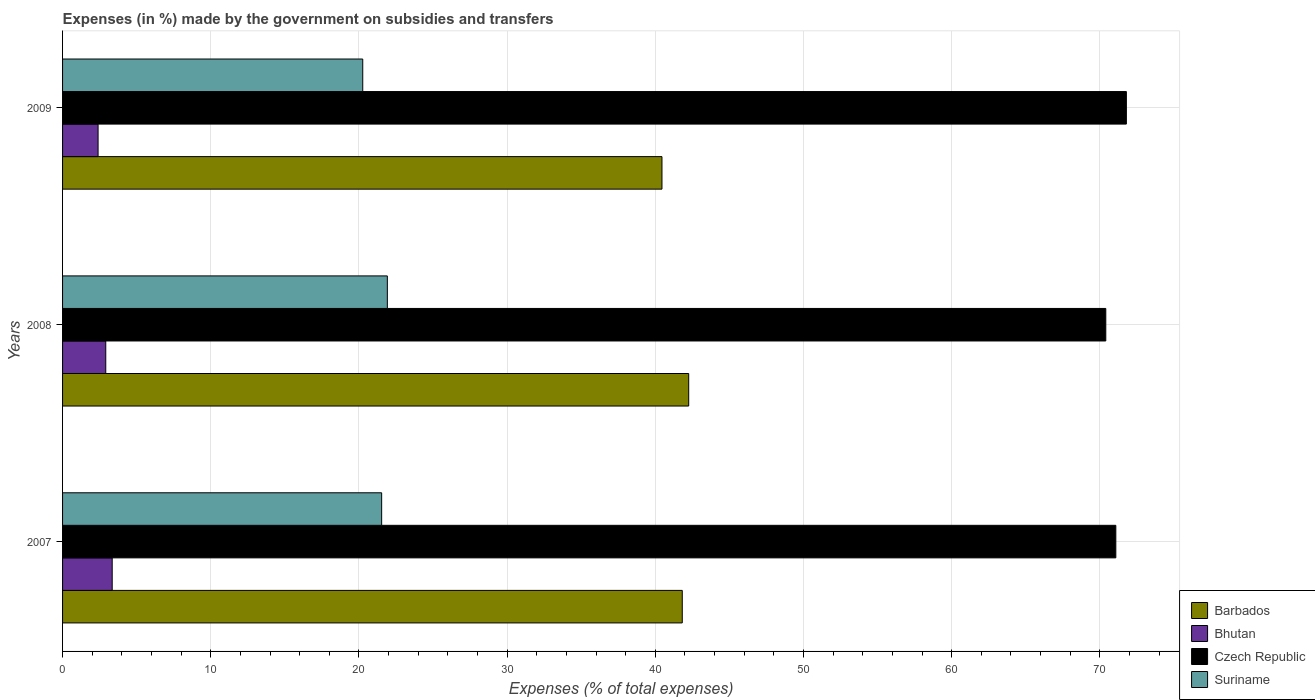Are the number of bars per tick equal to the number of legend labels?
Make the answer very short. Yes. What is the label of the 2nd group of bars from the top?
Your response must be concise. 2008. What is the percentage of expenses made by the government on subsidies and transfers in Czech Republic in 2007?
Your response must be concise. 71.08. Across all years, what is the maximum percentage of expenses made by the government on subsidies and transfers in Bhutan?
Keep it short and to the point. 3.35. Across all years, what is the minimum percentage of expenses made by the government on subsidies and transfers in Suriname?
Offer a terse response. 20.26. In which year was the percentage of expenses made by the government on subsidies and transfers in Suriname minimum?
Provide a short and direct response. 2009. What is the total percentage of expenses made by the government on subsidies and transfers in Bhutan in the graph?
Keep it short and to the point. 8.66. What is the difference between the percentage of expenses made by the government on subsidies and transfers in Barbados in 2007 and that in 2008?
Ensure brevity in your answer.  -0.44. What is the difference between the percentage of expenses made by the government on subsidies and transfers in Suriname in 2008 and the percentage of expenses made by the government on subsidies and transfers in Bhutan in 2007?
Ensure brevity in your answer.  18.57. What is the average percentage of expenses made by the government on subsidies and transfers in Czech Republic per year?
Your response must be concise. 71.09. In the year 2008, what is the difference between the percentage of expenses made by the government on subsidies and transfers in Suriname and percentage of expenses made by the government on subsidies and transfers in Czech Republic?
Provide a succinct answer. -48.49. What is the ratio of the percentage of expenses made by the government on subsidies and transfers in Bhutan in 2007 to that in 2008?
Provide a short and direct response. 1.15. What is the difference between the highest and the second highest percentage of expenses made by the government on subsidies and transfers in Bhutan?
Provide a succinct answer. 0.43. What is the difference between the highest and the lowest percentage of expenses made by the government on subsidies and transfers in Czech Republic?
Give a very brief answer. 1.39. In how many years, is the percentage of expenses made by the government on subsidies and transfers in Barbados greater than the average percentage of expenses made by the government on subsidies and transfers in Barbados taken over all years?
Ensure brevity in your answer.  2. Is it the case that in every year, the sum of the percentage of expenses made by the government on subsidies and transfers in Bhutan and percentage of expenses made by the government on subsidies and transfers in Suriname is greater than the sum of percentage of expenses made by the government on subsidies and transfers in Barbados and percentage of expenses made by the government on subsidies and transfers in Czech Republic?
Offer a very short reply. No. What does the 2nd bar from the top in 2007 represents?
Give a very brief answer. Czech Republic. What does the 4th bar from the bottom in 2008 represents?
Provide a short and direct response. Suriname. Is it the case that in every year, the sum of the percentage of expenses made by the government on subsidies and transfers in Czech Republic and percentage of expenses made by the government on subsidies and transfers in Suriname is greater than the percentage of expenses made by the government on subsidies and transfers in Barbados?
Your response must be concise. Yes. How many bars are there?
Give a very brief answer. 12. Are all the bars in the graph horizontal?
Make the answer very short. Yes. How many years are there in the graph?
Give a very brief answer. 3. Are the values on the major ticks of X-axis written in scientific E-notation?
Your response must be concise. No. Does the graph contain grids?
Offer a terse response. Yes. Where does the legend appear in the graph?
Ensure brevity in your answer.  Bottom right. How are the legend labels stacked?
Offer a very short reply. Vertical. What is the title of the graph?
Your answer should be compact. Expenses (in %) made by the government on subsidies and transfers. Does "Bahamas" appear as one of the legend labels in the graph?
Your response must be concise. No. What is the label or title of the X-axis?
Your response must be concise. Expenses (% of total expenses). What is the Expenses (% of total expenses) in Barbados in 2007?
Your answer should be compact. 41.82. What is the Expenses (% of total expenses) of Bhutan in 2007?
Provide a succinct answer. 3.35. What is the Expenses (% of total expenses) of Czech Republic in 2007?
Offer a very short reply. 71.08. What is the Expenses (% of total expenses) in Suriname in 2007?
Your answer should be very brief. 21.53. What is the Expenses (% of total expenses) of Barbados in 2008?
Provide a short and direct response. 42.26. What is the Expenses (% of total expenses) in Bhutan in 2008?
Your response must be concise. 2.92. What is the Expenses (% of total expenses) of Czech Republic in 2008?
Your answer should be compact. 70.4. What is the Expenses (% of total expenses) of Suriname in 2008?
Your response must be concise. 21.92. What is the Expenses (% of total expenses) of Barbados in 2009?
Provide a succinct answer. 40.45. What is the Expenses (% of total expenses) of Bhutan in 2009?
Make the answer very short. 2.4. What is the Expenses (% of total expenses) in Czech Republic in 2009?
Offer a very short reply. 71.79. What is the Expenses (% of total expenses) of Suriname in 2009?
Your answer should be compact. 20.26. Across all years, what is the maximum Expenses (% of total expenses) of Barbados?
Your answer should be very brief. 42.26. Across all years, what is the maximum Expenses (% of total expenses) of Bhutan?
Your answer should be very brief. 3.35. Across all years, what is the maximum Expenses (% of total expenses) in Czech Republic?
Your answer should be compact. 71.79. Across all years, what is the maximum Expenses (% of total expenses) in Suriname?
Offer a very short reply. 21.92. Across all years, what is the minimum Expenses (% of total expenses) of Barbados?
Offer a very short reply. 40.45. Across all years, what is the minimum Expenses (% of total expenses) in Bhutan?
Offer a terse response. 2.4. Across all years, what is the minimum Expenses (% of total expenses) in Czech Republic?
Give a very brief answer. 70.4. Across all years, what is the minimum Expenses (% of total expenses) of Suriname?
Offer a terse response. 20.26. What is the total Expenses (% of total expenses) in Barbados in the graph?
Keep it short and to the point. 124.53. What is the total Expenses (% of total expenses) of Bhutan in the graph?
Give a very brief answer. 8.66. What is the total Expenses (% of total expenses) in Czech Republic in the graph?
Keep it short and to the point. 213.27. What is the total Expenses (% of total expenses) of Suriname in the graph?
Provide a succinct answer. 63.71. What is the difference between the Expenses (% of total expenses) of Barbados in 2007 and that in 2008?
Provide a succinct answer. -0.44. What is the difference between the Expenses (% of total expenses) in Bhutan in 2007 and that in 2008?
Offer a terse response. 0.43. What is the difference between the Expenses (% of total expenses) in Czech Republic in 2007 and that in 2008?
Your response must be concise. 0.68. What is the difference between the Expenses (% of total expenses) in Suriname in 2007 and that in 2008?
Offer a terse response. -0.38. What is the difference between the Expenses (% of total expenses) in Barbados in 2007 and that in 2009?
Offer a terse response. 1.37. What is the difference between the Expenses (% of total expenses) of Bhutan in 2007 and that in 2009?
Offer a terse response. 0.95. What is the difference between the Expenses (% of total expenses) of Czech Republic in 2007 and that in 2009?
Your answer should be very brief. -0.71. What is the difference between the Expenses (% of total expenses) in Suriname in 2007 and that in 2009?
Make the answer very short. 1.28. What is the difference between the Expenses (% of total expenses) of Barbados in 2008 and that in 2009?
Your answer should be very brief. 1.8. What is the difference between the Expenses (% of total expenses) in Bhutan in 2008 and that in 2009?
Make the answer very short. 0.52. What is the difference between the Expenses (% of total expenses) in Czech Republic in 2008 and that in 2009?
Your answer should be compact. -1.39. What is the difference between the Expenses (% of total expenses) of Suriname in 2008 and that in 2009?
Provide a succinct answer. 1.66. What is the difference between the Expenses (% of total expenses) of Barbados in 2007 and the Expenses (% of total expenses) of Bhutan in 2008?
Your response must be concise. 38.9. What is the difference between the Expenses (% of total expenses) of Barbados in 2007 and the Expenses (% of total expenses) of Czech Republic in 2008?
Your answer should be very brief. -28.58. What is the difference between the Expenses (% of total expenses) in Barbados in 2007 and the Expenses (% of total expenses) in Suriname in 2008?
Offer a terse response. 19.9. What is the difference between the Expenses (% of total expenses) of Bhutan in 2007 and the Expenses (% of total expenses) of Czech Republic in 2008?
Give a very brief answer. -67.05. What is the difference between the Expenses (% of total expenses) in Bhutan in 2007 and the Expenses (% of total expenses) in Suriname in 2008?
Provide a succinct answer. -18.57. What is the difference between the Expenses (% of total expenses) in Czech Republic in 2007 and the Expenses (% of total expenses) in Suriname in 2008?
Ensure brevity in your answer.  49.16. What is the difference between the Expenses (% of total expenses) of Barbados in 2007 and the Expenses (% of total expenses) of Bhutan in 2009?
Give a very brief answer. 39.42. What is the difference between the Expenses (% of total expenses) in Barbados in 2007 and the Expenses (% of total expenses) in Czech Republic in 2009?
Make the answer very short. -29.97. What is the difference between the Expenses (% of total expenses) in Barbados in 2007 and the Expenses (% of total expenses) in Suriname in 2009?
Your answer should be very brief. 21.56. What is the difference between the Expenses (% of total expenses) in Bhutan in 2007 and the Expenses (% of total expenses) in Czech Republic in 2009?
Offer a terse response. -68.44. What is the difference between the Expenses (% of total expenses) of Bhutan in 2007 and the Expenses (% of total expenses) of Suriname in 2009?
Provide a short and direct response. -16.91. What is the difference between the Expenses (% of total expenses) of Czech Republic in 2007 and the Expenses (% of total expenses) of Suriname in 2009?
Ensure brevity in your answer.  50.82. What is the difference between the Expenses (% of total expenses) in Barbados in 2008 and the Expenses (% of total expenses) in Bhutan in 2009?
Offer a very short reply. 39.86. What is the difference between the Expenses (% of total expenses) of Barbados in 2008 and the Expenses (% of total expenses) of Czech Republic in 2009?
Your answer should be very brief. -29.54. What is the difference between the Expenses (% of total expenses) of Barbados in 2008 and the Expenses (% of total expenses) of Suriname in 2009?
Your response must be concise. 22. What is the difference between the Expenses (% of total expenses) of Bhutan in 2008 and the Expenses (% of total expenses) of Czech Republic in 2009?
Offer a terse response. -68.88. What is the difference between the Expenses (% of total expenses) in Bhutan in 2008 and the Expenses (% of total expenses) in Suriname in 2009?
Offer a terse response. -17.34. What is the difference between the Expenses (% of total expenses) of Czech Republic in 2008 and the Expenses (% of total expenses) of Suriname in 2009?
Provide a succinct answer. 50.15. What is the average Expenses (% of total expenses) in Barbados per year?
Your answer should be compact. 41.51. What is the average Expenses (% of total expenses) in Bhutan per year?
Make the answer very short. 2.89. What is the average Expenses (% of total expenses) in Czech Republic per year?
Provide a short and direct response. 71.09. What is the average Expenses (% of total expenses) in Suriname per year?
Offer a terse response. 21.24. In the year 2007, what is the difference between the Expenses (% of total expenses) in Barbados and Expenses (% of total expenses) in Bhutan?
Offer a very short reply. 38.47. In the year 2007, what is the difference between the Expenses (% of total expenses) in Barbados and Expenses (% of total expenses) in Czech Republic?
Give a very brief answer. -29.26. In the year 2007, what is the difference between the Expenses (% of total expenses) in Barbados and Expenses (% of total expenses) in Suriname?
Make the answer very short. 20.29. In the year 2007, what is the difference between the Expenses (% of total expenses) of Bhutan and Expenses (% of total expenses) of Czech Republic?
Make the answer very short. -67.73. In the year 2007, what is the difference between the Expenses (% of total expenses) in Bhutan and Expenses (% of total expenses) in Suriname?
Provide a succinct answer. -18.18. In the year 2007, what is the difference between the Expenses (% of total expenses) of Czech Republic and Expenses (% of total expenses) of Suriname?
Your answer should be compact. 49.55. In the year 2008, what is the difference between the Expenses (% of total expenses) in Barbados and Expenses (% of total expenses) in Bhutan?
Your answer should be compact. 39.34. In the year 2008, what is the difference between the Expenses (% of total expenses) of Barbados and Expenses (% of total expenses) of Czech Republic?
Provide a succinct answer. -28.15. In the year 2008, what is the difference between the Expenses (% of total expenses) in Barbados and Expenses (% of total expenses) in Suriname?
Your answer should be compact. 20.34. In the year 2008, what is the difference between the Expenses (% of total expenses) of Bhutan and Expenses (% of total expenses) of Czech Republic?
Your response must be concise. -67.49. In the year 2008, what is the difference between the Expenses (% of total expenses) of Bhutan and Expenses (% of total expenses) of Suriname?
Offer a very short reply. -19. In the year 2008, what is the difference between the Expenses (% of total expenses) of Czech Republic and Expenses (% of total expenses) of Suriname?
Your response must be concise. 48.49. In the year 2009, what is the difference between the Expenses (% of total expenses) in Barbados and Expenses (% of total expenses) in Bhutan?
Your answer should be compact. 38.05. In the year 2009, what is the difference between the Expenses (% of total expenses) in Barbados and Expenses (% of total expenses) in Czech Republic?
Provide a succinct answer. -31.34. In the year 2009, what is the difference between the Expenses (% of total expenses) in Barbados and Expenses (% of total expenses) in Suriname?
Provide a short and direct response. 20.19. In the year 2009, what is the difference between the Expenses (% of total expenses) in Bhutan and Expenses (% of total expenses) in Czech Republic?
Ensure brevity in your answer.  -69.39. In the year 2009, what is the difference between the Expenses (% of total expenses) of Bhutan and Expenses (% of total expenses) of Suriname?
Your answer should be compact. -17.86. In the year 2009, what is the difference between the Expenses (% of total expenses) of Czech Republic and Expenses (% of total expenses) of Suriname?
Give a very brief answer. 51.53. What is the ratio of the Expenses (% of total expenses) of Bhutan in 2007 to that in 2008?
Make the answer very short. 1.15. What is the ratio of the Expenses (% of total expenses) in Czech Republic in 2007 to that in 2008?
Make the answer very short. 1.01. What is the ratio of the Expenses (% of total expenses) in Suriname in 2007 to that in 2008?
Provide a short and direct response. 0.98. What is the ratio of the Expenses (% of total expenses) in Barbados in 2007 to that in 2009?
Make the answer very short. 1.03. What is the ratio of the Expenses (% of total expenses) of Bhutan in 2007 to that in 2009?
Provide a succinct answer. 1.4. What is the ratio of the Expenses (% of total expenses) of Suriname in 2007 to that in 2009?
Provide a short and direct response. 1.06. What is the ratio of the Expenses (% of total expenses) of Barbados in 2008 to that in 2009?
Give a very brief answer. 1.04. What is the ratio of the Expenses (% of total expenses) in Bhutan in 2008 to that in 2009?
Provide a short and direct response. 1.22. What is the ratio of the Expenses (% of total expenses) in Czech Republic in 2008 to that in 2009?
Your answer should be very brief. 0.98. What is the ratio of the Expenses (% of total expenses) of Suriname in 2008 to that in 2009?
Ensure brevity in your answer.  1.08. What is the difference between the highest and the second highest Expenses (% of total expenses) of Barbados?
Offer a terse response. 0.44. What is the difference between the highest and the second highest Expenses (% of total expenses) in Bhutan?
Offer a very short reply. 0.43. What is the difference between the highest and the second highest Expenses (% of total expenses) of Czech Republic?
Your response must be concise. 0.71. What is the difference between the highest and the second highest Expenses (% of total expenses) in Suriname?
Your answer should be compact. 0.38. What is the difference between the highest and the lowest Expenses (% of total expenses) of Barbados?
Keep it short and to the point. 1.8. What is the difference between the highest and the lowest Expenses (% of total expenses) in Bhutan?
Provide a short and direct response. 0.95. What is the difference between the highest and the lowest Expenses (% of total expenses) in Czech Republic?
Your answer should be very brief. 1.39. What is the difference between the highest and the lowest Expenses (% of total expenses) in Suriname?
Offer a terse response. 1.66. 